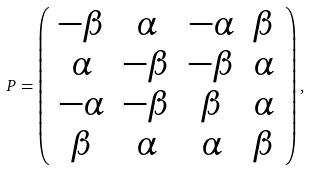<formula> <loc_0><loc_0><loc_500><loc_500>P = \left ( \begin{array} { c c c c } - \beta & \alpha & - \alpha & \beta \\ \alpha & - \beta & - \beta & \alpha \\ - \alpha & - \beta & \beta & \alpha \\ \beta & \alpha & \alpha & \beta \\ \end{array} \right ) ,</formula> 